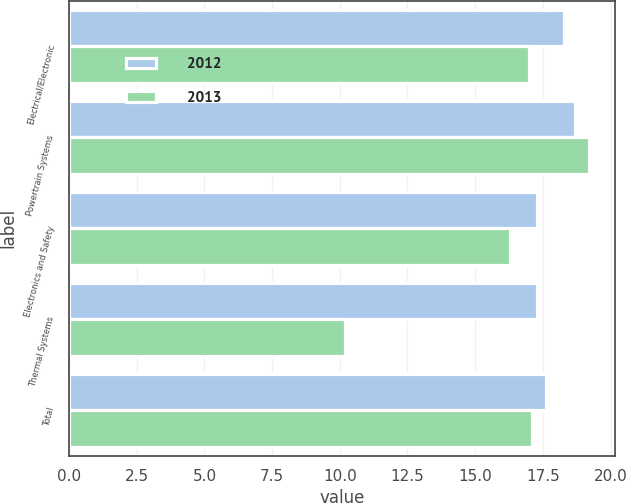<chart> <loc_0><loc_0><loc_500><loc_500><stacked_bar_chart><ecel><fcel>Electrical/Electronic<fcel>Powertrain Systems<fcel>Electronics and Safety<fcel>Thermal Systems<fcel>Total<nl><fcel>2012<fcel>18.3<fcel>18.7<fcel>17.3<fcel>17.3<fcel>17.6<nl><fcel>2013<fcel>17<fcel>19.2<fcel>16.3<fcel>10.2<fcel>17.1<nl></chart> 